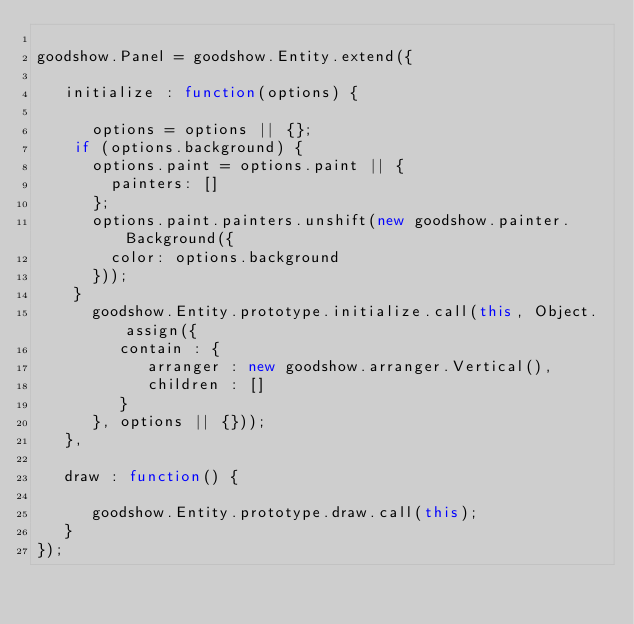<code> <loc_0><loc_0><loc_500><loc_500><_JavaScript_>
goodshow.Panel = goodshow.Entity.extend({
   
   initialize : function(options) {
      
      options = options || {};
		if (options.background) {
			options.paint = options.paint || {
				painters: []
			};
			options.paint.painters.unshift(new goodshow.painter.Background({
				color: options.background
			}));
		}
      goodshow.Entity.prototype.initialize.call(this, Object.assign({
         contain : {
            arranger : new goodshow.arranger.Vertical(),
            children : []
         }
      }, options || {}));
   },
   
   draw : function() {
      
      goodshow.Entity.prototype.draw.call(this);
   }
});
</code> 